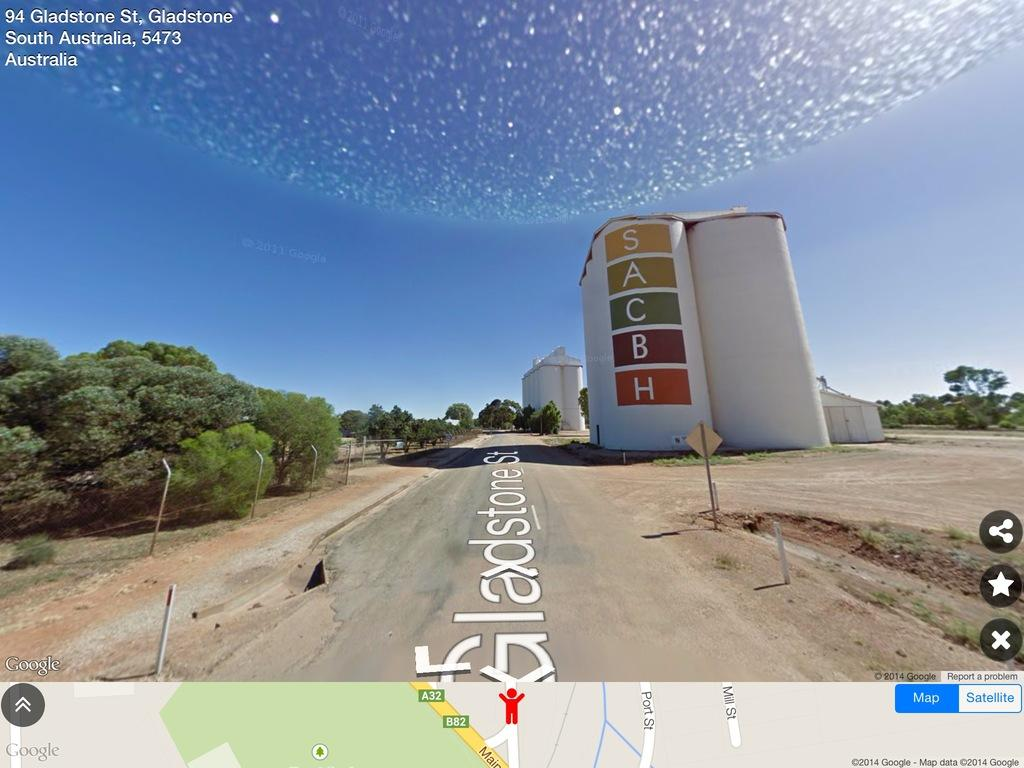What type of structures can be seen in the image? There are buildings in the image. What natural elements are present in the image? There are trees in the image. What man-made objects can be seen in the image? There are poles in the image. What type of pathway is visible in the image? There is a road in the image. What additional object is present in the image? There is a board in the image. What information is provided in the top right corner of the image? There is text in the top right corner of the image. What type of image is located at the bottom of the picture? There is an image of a map at the bottom of the picture. Can you tell me how many cats are sitting on the board in the image? There are no cats present in the image; it features buildings, trees, poles, a road, a board, text in the top right corner, and an image of a map at the bottom. What type of knee is visible in the image? There are no knees present in the image. 